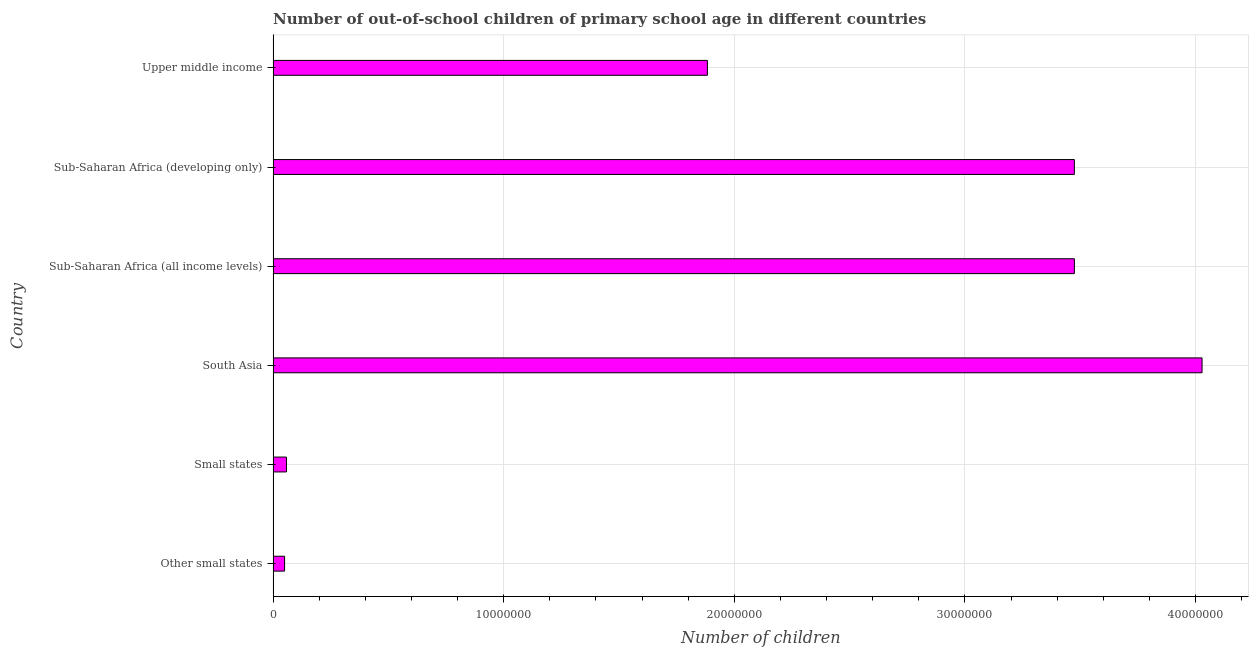Does the graph contain any zero values?
Provide a short and direct response. No. What is the title of the graph?
Your answer should be compact. Number of out-of-school children of primary school age in different countries. What is the label or title of the X-axis?
Your answer should be very brief. Number of children. What is the number of out-of-school children in Upper middle income?
Provide a short and direct response. 1.88e+07. Across all countries, what is the maximum number of out-of-school children?
Give a very brief answer. 4.03e+07. Across all countries, what is the minimum number of out-of-school children?
Keep it short and to the point. 4.97e+05. In which country was the number of out-of-school children minimum?
Keep it short and to the point. Other small states. What is the sum of the number of out-of-school children?
Ensure brevity in your answer.  1.30e+08. What is the difference between the number of out-of-school children in Small states and Sub-Saharan Africa (developing only)?
Provide a succinct answer. -3.42e+07. What is the average number of out-of-school children per country?
Offer a terse response. 2.16e+07. What is the median number of out-of-school children?
Your answer should be compact. 2.68e+07. Is the number of out-of-school children in Sub-Saharan Africa (all income levels) less than that in Sub-Saharan Africa (developing only)?
Your answer should be compact. No. Is the difference between the number of out-of-school children in Small states and Sub-Saharan Africa (all income levels) greater than the difference between any two countries?
Offer a terse response. No. What is the difference between the highest and the second highest number of out-of-school children?
Keep it short and to the point. 5.54e+06. What is the difference between the highest and the lowest number of out-of-school children?
Your response must be concise. 3.98e+07. In how many countries, is the number of out-of-school children greater than the average number of out-of-school children taken over all countries?
Your answer should be compact. 3. How many bars are there?
Offer a terse response. 6. How many countries are there in the graph?
Make the answer very short. 6. What is the difference between two consecutive major ticks on the X-axis?
Your response must be concise. 1.00e+07. Are the values on the major ticks of X-axis written in scientific E-notation?
Offer a terse response. No. What is the Number of children of Other small states?
Offer a very short reply. 4.97e+05. What is the Number of children of Small states?
Provide a succinct answer. 5.79e+05. What is the Number of children in South Asia?
Keep it short and to the point. 4.03e+07. What is the Number of children in Sub-Saharan Africa (all income levels)?
Ensure brevity in your answer.  3.47e+07. What is the Number of children in Sub-Saharan Africa (developing only)?
Your response must be concise. 3.47e+07. What is the Number of children in Upper middle income?
Your answer should be very brief. 1.88e+07. What is the difference between the Number of children in Other small states and Small states?
Your answer should be compact. -8.25e+04. What is the difference between the Number of children in Other small states and South Asia?
Your answer should be very brief. -3.98e+07. What is the difference between the Number of children in Other small states and Sub-Saharan Africa (all income levels)?
Make the answer very short. -3.42e+07. What is the difference between the Number of children in Other small states and Sub-Saharan Africa (developing only)?
Your response must be concise. -3.42e+07. What is the difference between the Number of children in Other small states and Upper middle income?
Make the answer very short. -1.83e+07. What is the difference between the Number of children in Small states and South Asia?
Give a very brief answer. -3.97e+07. What is the difference between the Number of children in Small states and Sub-Saharan Africa (all income levels)?
Your answer should be very brief. -3.42e+07. What is the difference between the Number of children in Small states and Sub-Saharan Africa (developing only)?
Your answer should be compact. -3.42e+07. What is the difference between the Number of children in Small states and Upper middle income?
Your answer should be compact. -1.83e+07. What is the difference between the Number of children in South Asia and Sub-Saharan Africa (all income levels)?
Give a very brief answer. 5.54e+06. What is the difference between the Number of children in South Asia and Sub-Saharan Africa (developing only)?
Provide a short and direct response. 5.54e+06. What is the difference between the Number of children in South Asia and Upper middle income?
Offer a terse response. 2.14e+07. What is the difference between the Number of children in Sub-Saharan Africa (all income levels) and Sub-Saharan Africa (developing only)?
Offer a very short reply. 756. What is the difference between the Number of children in Sub-Saharan Africa (all income levels) and Upper middle income?
Offer a terse response. 1.59e+07. What is the difference between the Number of children in Sub-Saharan Africa (developing only) and Upper middle income?
Your answer should be compact. 1.59e+07. What is the ratio of the Number of children in Other small states to that in Small states?
Make the answer very short. 0.86. What is the ratio of the Number of children in Other small states to that in South Asia?
Make the answer very short. 0.01. What is the ratio of the Number of children in Other small states to that in Sub-Saharan Africa (all income levels)?
Your answer should be compact. 0.01. What is the ratio of the Number of children in Other small states to that in Sub-Saharan Africa (developing only)?
Provide a short and direct response. 0.01. What is the ratio of the Number of children in Other small states to that in Upper middle income?
Give a very brief answer. 0.03. What is the ratio of the Number of children in Small states to that in South Asia?
Your response must be concise. 0.01. What is the ratio of the Number of children in Small states to that in Sub-Saharan Africa (all income levels)?
Offer a very short reply. 0.02. What is the ratio of the Number of children in Small states to that in Sub-Saharan Africa (developing only)?
Ensure brevity in your answer.  0.02. What is the ratio of the Number of children in Small states to that in Upper middle income?
Provide a succinct answer. 0.03. What is the ratio of the Number of children in South Asia to that in Sub-Saharan Africa (all income levels)?
Keep it short and to the point. 1.16. What is the ratio of the Number of children in South Asia to that in Sub-Saharan Africa (developing only)?
Ensure brevity in your answer.  1.16. What is the ratio of the Number of children in South Asia to that in Upper middle income?
Provide a short and direct response. 2.14. What is the ratio of the Number of children in Sub-Saharan Africa (all income levels) to that in Sub-Saharan Africa (developing only)?
Provide a short and direct response. 1. What is the ratio of the Number of children in Sub-Saharan Africa (all income levels) to that in Upper middle income?
Your answer should be compact. 1.84. What is the ratio of the Number of children in Sub-Saharan Africa (developing only) to that in Upper middle income?
Make the answer very short. 1.84. 